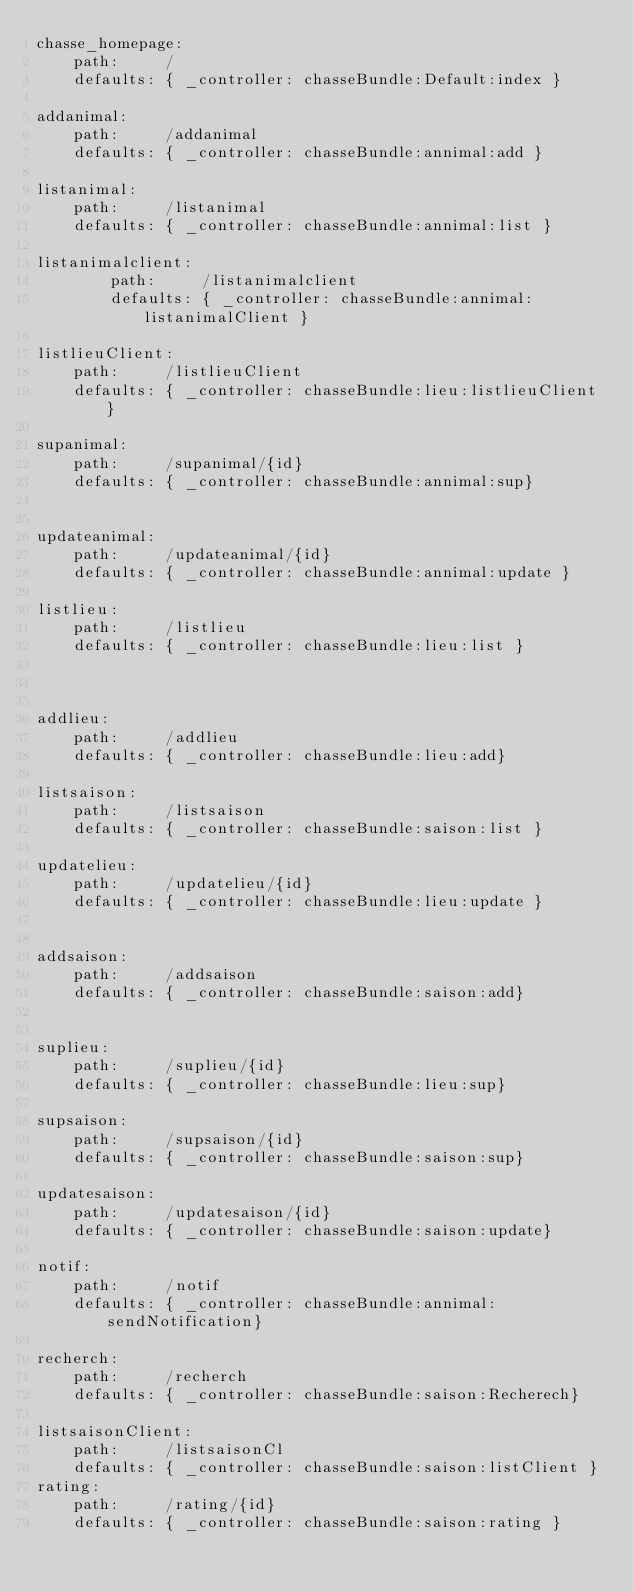<code> <loc_0><loc_0><loc_500><loc_500><_YAML_>chasse_homepage:
    path:     /
    defaults: { _controller: chasseBundle:Default:index }

addanimal:
    path:     /addanimal
    defaults: { _controller: chasseBundle:annimal:add }

listanimal:
    path:     /listanimal
    defaults: { _controller: chasseBundle:annimal:list }

listanimalclient:
        path:     /listanimalclient
        defaults: { _controller: chasseBundle:annimal:listanimalClient }

listlieuClient:
    path:     /listlieuClient
    defaults: { _controller: chasseBundle:lieu:listlieuClient }

supanimal:
    path:     /supanimal/{id}
    defaults: { _controller: chasseBundle:annimal:sup}


updateanimal:
    path:     /updateanimal/{id}
    defaults: { _controller: chasseBundle:annimal:update }

listlieu:
    path:     /listlieu
    defaults: { _controller: chasseBundle:lieu:list }



addlieu:
    path:     /addlieu
    defaults: { _controller: chasseBundle:lieu:add}

listsaison:
    path:     /listsaison
    defaults: { _controller: chasseBundle:saison:list }

updatelieu:
    path:     /updatelieu/{id}
    defaults: { _controller: chasseBundle:lieu:update }


addsaison:
    path:     /addsaison
    defaults: { _controller: chasseBundle:saison:add}


suplieu:
    path:     /suplieu/{id}
    defaults: { _controller: chasseBundle:lieu:sup}

supsaison:
    path:     /supsaison/{id}
    defaults: { _controller: chasseBundle:saison:sup}

updatesaison:
    path:     /updatesaison/{id}
    defaults: { _controller: chasseBundle:saison:update}

notif:
    path:     /notif
    defaults: { _controller: chasseBundle:annimal:sendNotification}

recherch:
    path:     /recherch
    defaults: { _controller: chasseBundle:saison:Recherech}

listsaisonClient:
    path:     /listsaisonCl
    defaults: { _controller: chasseBundle:saison:listClient }
rating:
    path:     /rating/{id}
    defaults: { _controller: chasseBundle:saison:rating }
</code> 